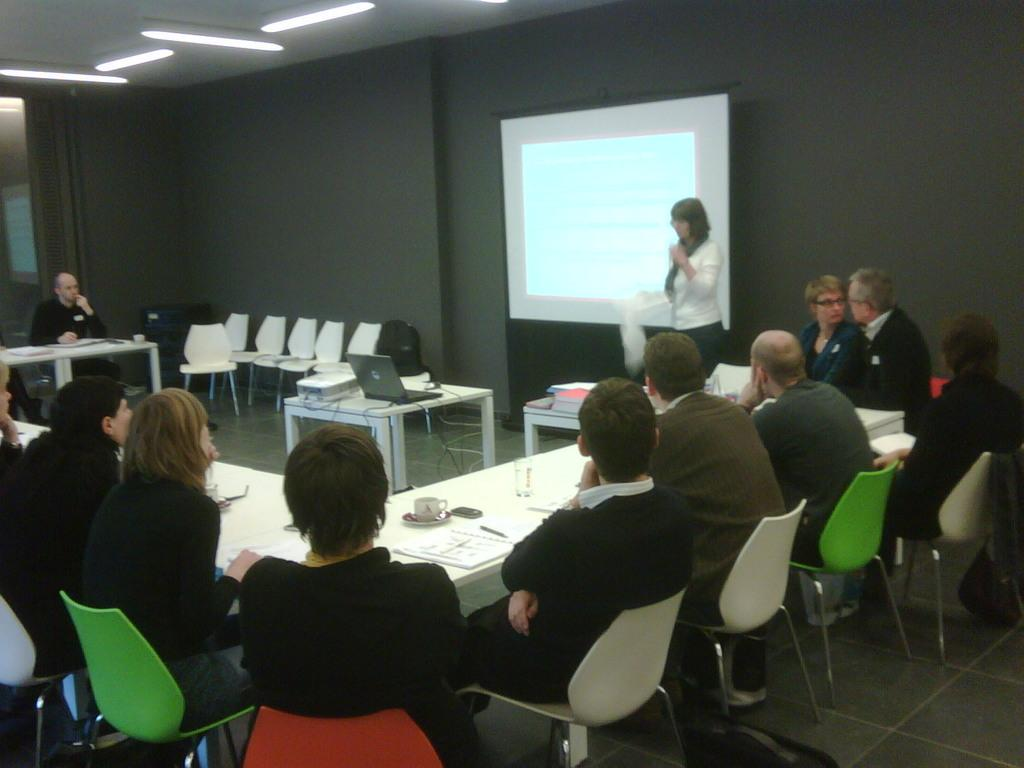What type of structure can be seen in the image? There is a wall in the image. What is the main object in the image? There is a screen in the image. What are the people in the image doing? The people are sitting on chairs in the image. What is on the table in the image? There is a table in the image with a laptop, a projector, papers, and a cup on it. What type of stove is visible in the image? There is no stove present in the image. How does the projector end the meeting in the image? The projector does not end the meeting in the image; it is simply an object on the table. 